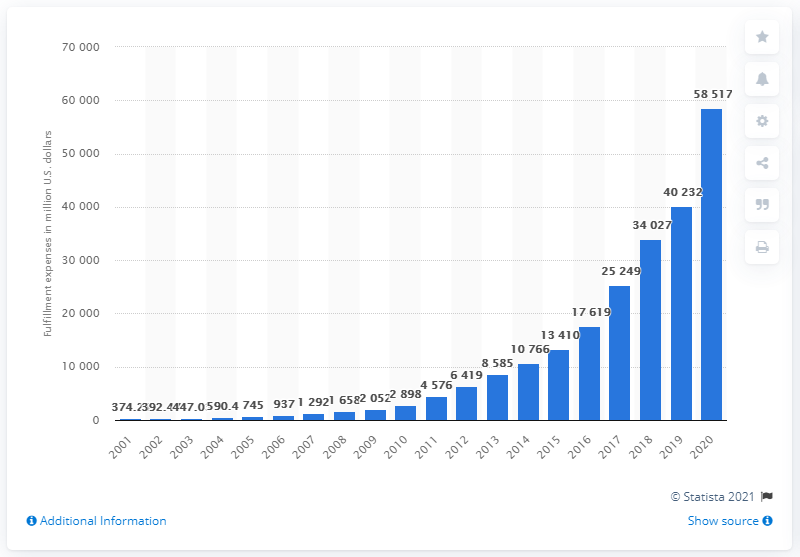List a handful of essential elements in this visual. In the most recent fiscal year, Amazon's fulfillment expenses totaled 58,517 